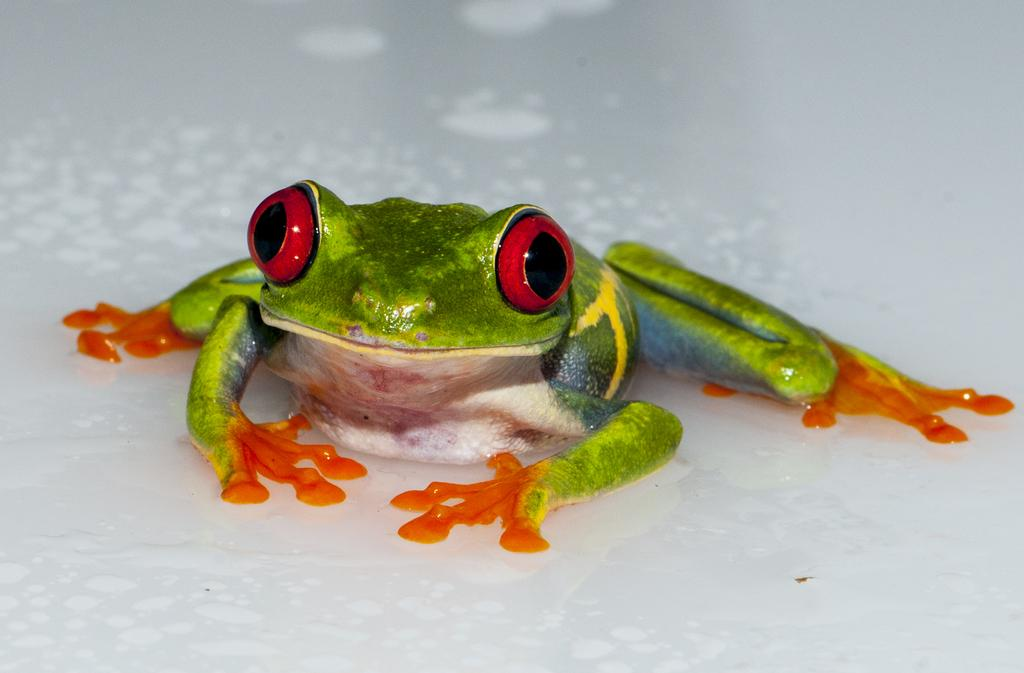What is the main subject of the image? The main subject of the image is a frog. Can you describe the surface on which the frog is situated? The frog is on a white surface. What type of ball is the frog holding in the image? There is no ball present in the image; it only features a frog on a white surface. What is the weight of the frog in the image? It is not possible to determine the weight of the frog from the image alone. 